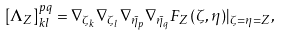Convert formula to latex. <formula><loc_0><loc_0><loc_500><loc_500>\left [ \Lambda _ { Z } \right ] ^ { p q } _ { k l } = \nabla _ { \zeta _ { k } } \nabla _ { \zeta _ { l } } \nabla _ { \bar { \eta } _ { p } } \nabla _ { \bar { \eta } _ { q } } F _ { Z } ( \zeta , \eta ) | _ { \zeta = \eta = Z } ,</formula> 